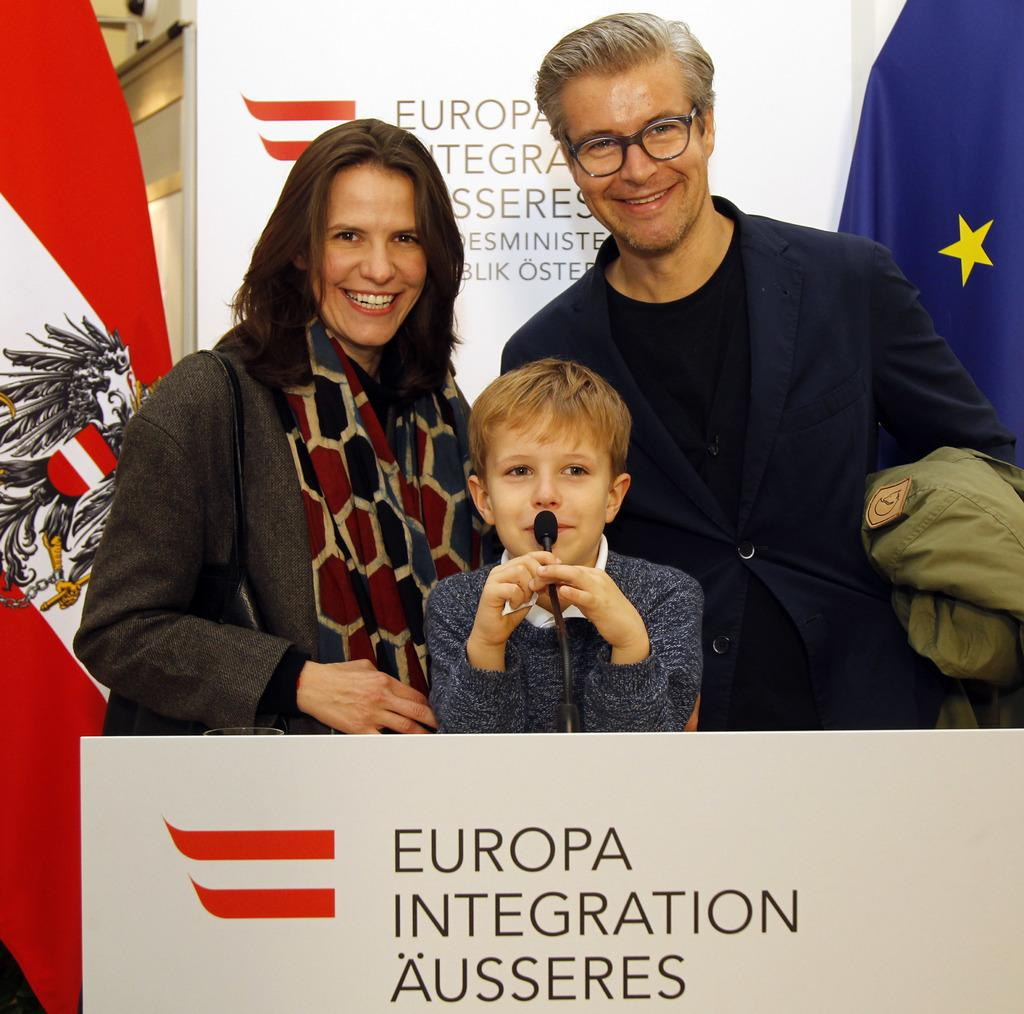What is the color of the banner in the image? The banner in the image is white. What colors are present on the flag in the image? The flag in the image has red and white colors. How many people are standing in the image? Three people are standing in the image. What is the boy holding in the image? The boy is holding a mic in the image. Can you see a bear playing with a balloon in the image? No, there is no bear or balloon present in the image. 